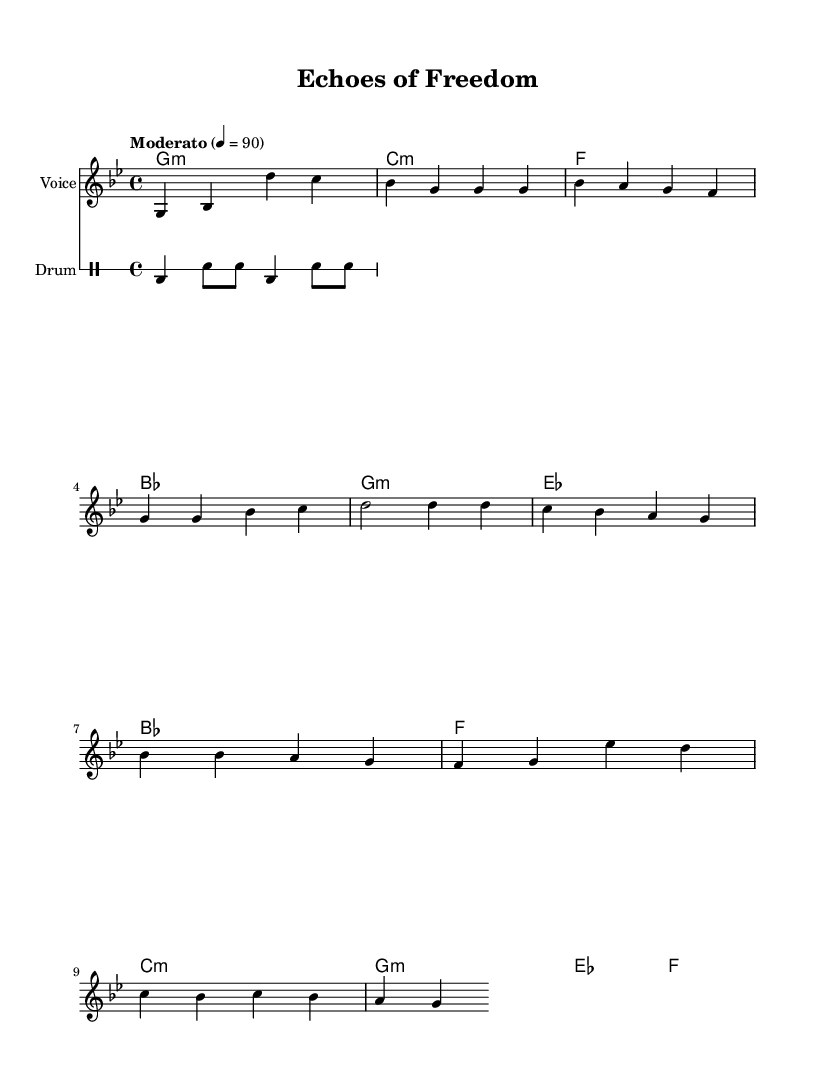What is the key signature of this music? The key signature is indicated at the beginning of the staff, showing two flats, which corresponds to G minor.
Answer: G minor What is the time signature of this piece? The time signature is visible in the beginning notation, indicating that there are four beats in each measure, denoted as 4/4.
Answer: 4/4 What is the tempo marking for this piece? The tempo marking appears at the start of the score, stating "Moderato" with a metronome marking of 90 beats per minute.
Answer: Moderato 4 = 90 How many measures are present in the chorus? By counting the measures in the section labeled as the chorus, we find there are four measures.
Answer: 4 What type of musical structure does the song use? The sheet music includes sections labeled as verse and chorus, demonstrating a common structure in folk songs that alternatingly presents thematic material.
Answer: Verse and Chorus What is a significant theme expressed in the lyrics of the first verse? Analyzing the text of the first verse, it reflects a connection to heritage and struggle, indicating themes of growth and resilience.
Answer: Heritage and struggle How do the drum patterns contribute to the overall feel of the song? The drum patterns indicated in the drummode provide a rhythmic foundation that enhances the folk and religious qualities of the piece, offering a steady pulse that complements the vocal lines.
Answer: Steady pulse 